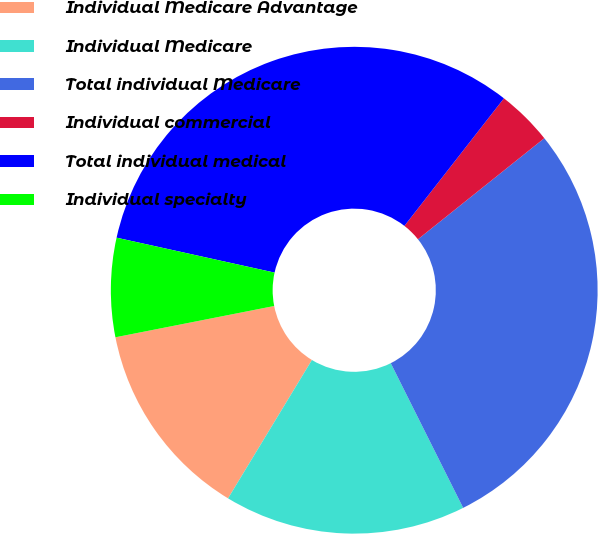Convert chart to OTSL. <chart><loc_0><loc_0><loc_500><loc_500><pie_chart><fcel>Individual Medicare Advantage<fcel>Individual Medicare<fcel>Total individual Medicare<fcel>Individual commercial<fcel>Total individual medical<fcel>Individual specialty<nl><fcel>13.23%<fcel>16.06%<fcel>28.35%<fcel>3.72%<fcel>32.08%<fcel>6.56%<nl></chart> 